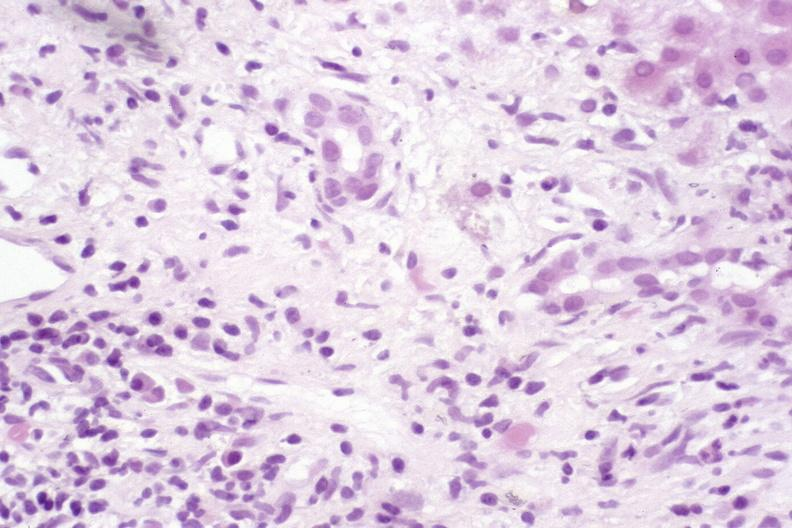what is present?
Answer the question using a single word or phrase. Liver 